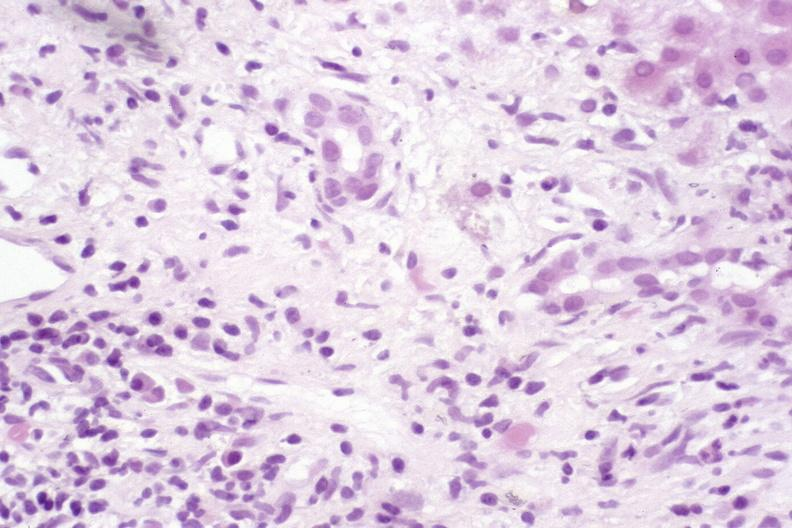what is present?
Answer the question using a single word or phrase. Liver 